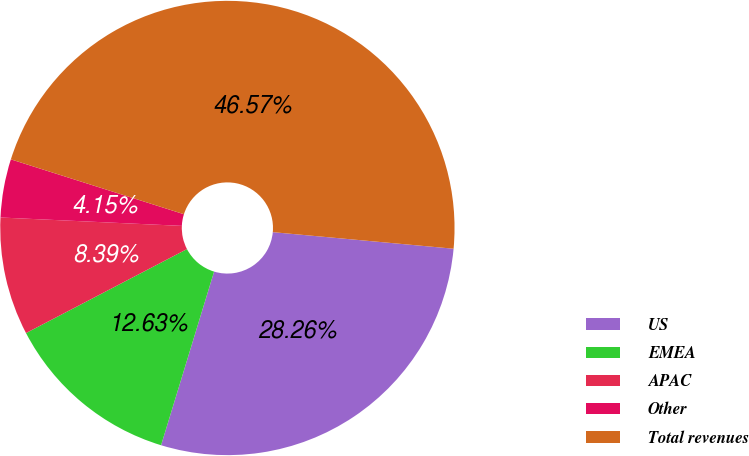Convert chart. <chart><loc_0><loc_0><loc_500><loc_500><pie_chart><fcel>US<fcel>EMEA<fcel>APAC<fcel>Other<fcel>Total revenues<nl><fcel>28.26%<fcel>12.63%<fcel>8.39%<fcel>4.15%<fcel>46.57%<nl></chart> 